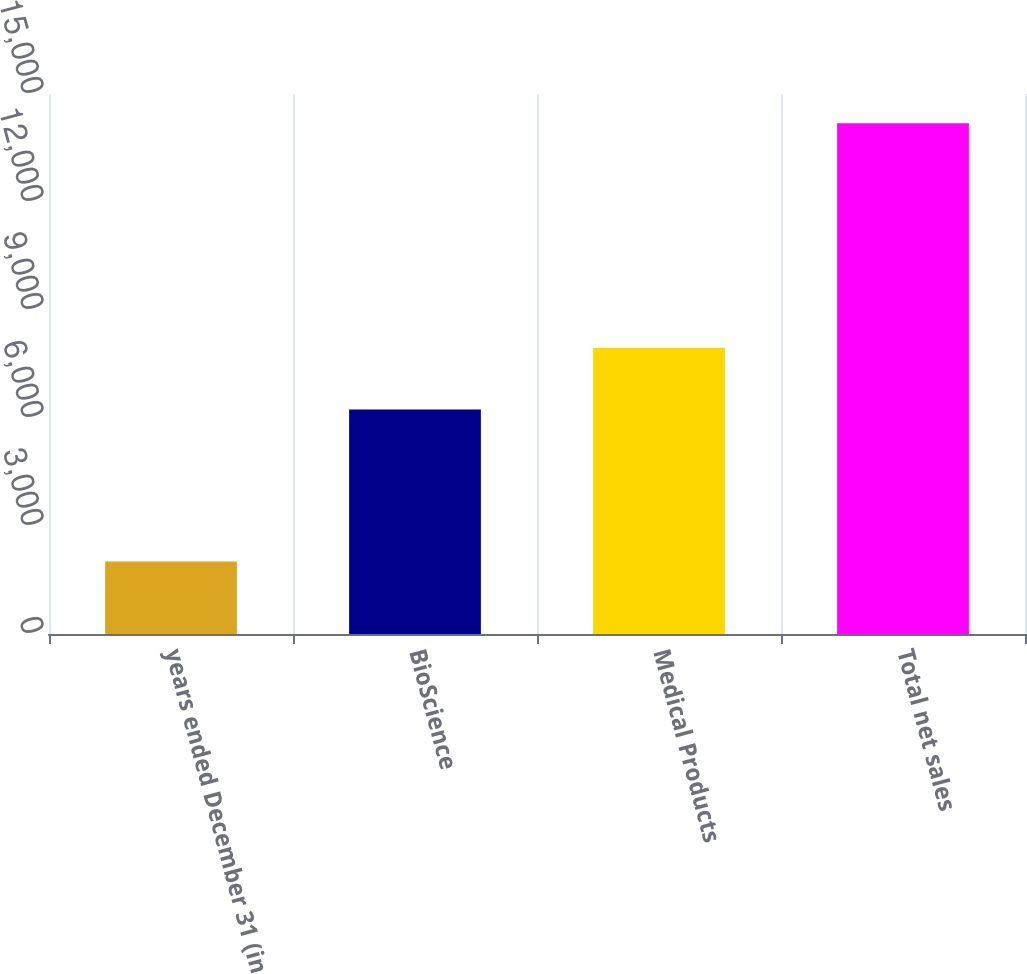Convert chart. <chart><loc_0><loc_0><loc_500><loc_500><bar_chart><fcel>years ended December 31 (in<fcel>BioScience<fcel>Medical Products<fcel>Total net sales<nl><fcel>2012<fcel>6237<fcel>7953<fcel>14190<nl></chart> 